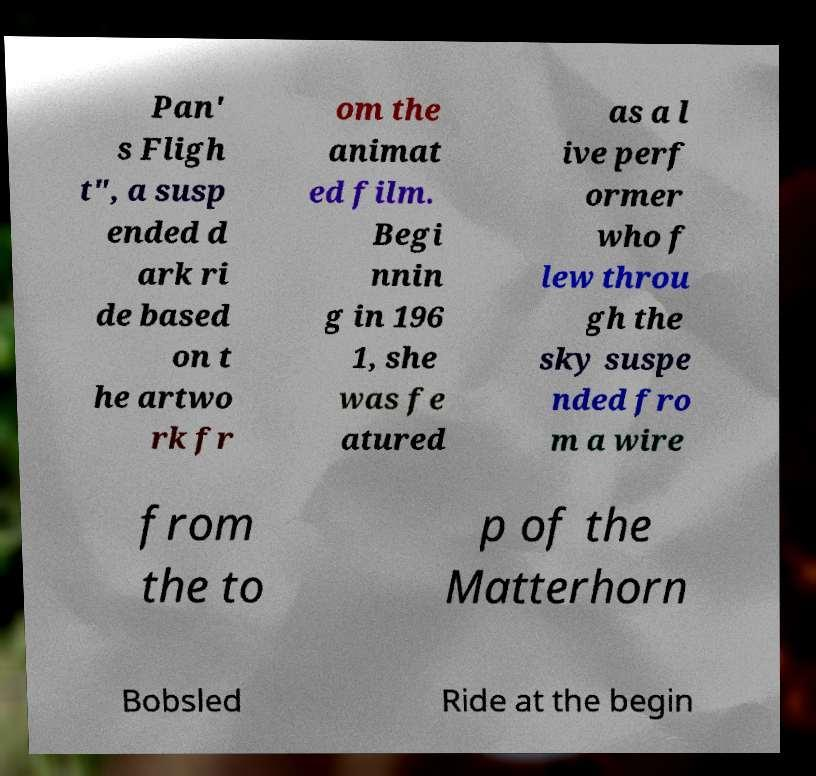Could you assist in decoding the text presented in this image and type it out clearly? Pan' s Fligh t", a susp ended d ark ri de based on t he artwo rk fr om the animat ed film. Begi nnin g in 196 1, she was fe atured as a l ive perf ormer who f lew throu gh the sky suspe nded fro m a wire from the to p of the Matterhorn Bobsled Ride at the begin 